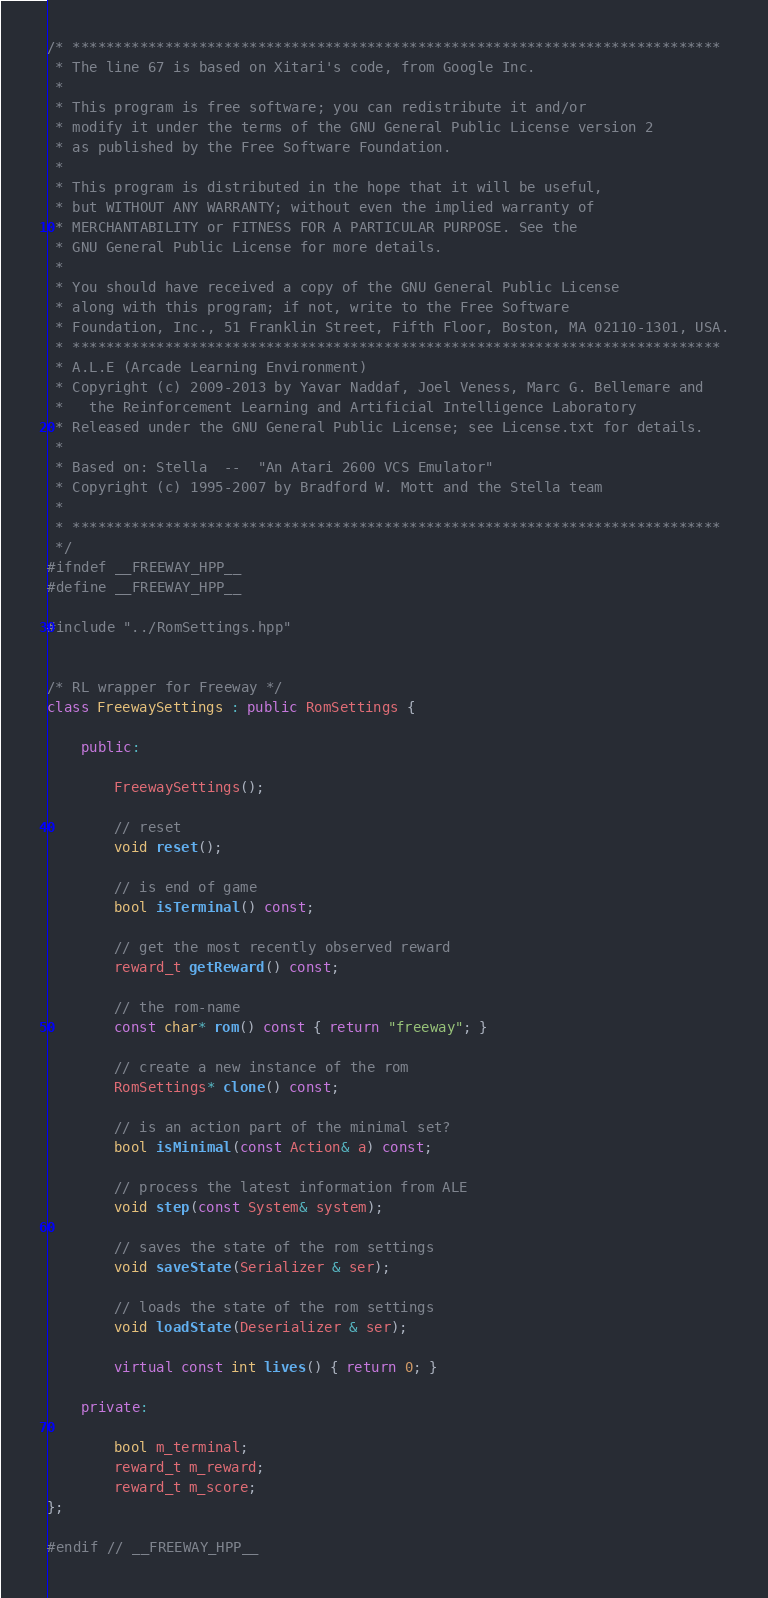<code> <loc_0><loc_0><loc_500><loc_500><_C++_>/* *****************************************************************************
 * The line 67 is based on Xitari's code, from Google Inc.
 *
 * This program is free software; you can redistribute it and/or
 * modify it under the terms of the GNU General Public License version 2
 * as published by the Free Software Foundation.
 *
 * This program is distributed in the hope that it will be useful,
 * but WITHOUT ANY WARRANTY; without even the implied warranty of
 * MERCHANTABILITY or FITNESS FOR A PARTICULAR PURPOSE. See the
 * GNU General Public License for more details.
 *
 * You should have received a copy of the GNU General Public License
 * along with this program; if not, write to the Free Software
 * Foundation, Inc., 51 Franklin Street, Fifth Floor, Boston, MA 02110-1301, USA.
 * *****************************************************************************
 * A.L.E (Arcade Learning Environment)
 * Copyright (c) 2009-2013 by Yavar Naddaf, Joel Veness, Marc G. Bellemare and 
 *   the Reinforcement Learning and Artificial Intelligence Laboratory
 * Released under the GNU General Public License; see License.txt for details. 
 *
 * Based on: Stella  --  "An Atari 2600 VCS Emulator"
 * Copyright (c) 1995-2007 by Bradford W. Mott and the Stella team
 *
 * *****************************************************************************
 */
#ifndef __FREEWAY_HPP__
#define __FREEWAY_HPP__

#include "../RomSettings.hpp"


/* RL wrapper for Freeway */
class FreewaySettings : public RomSettings {

    public:

        FreewaySettings();

        // reset
        void reset();

        // is end of game
        bool isTerminal() const;

        // get the most recently observed reward
        reward_t getReward() const;

        // the rom-name
        const char* rom() const { return "freeway"; }

        // create a new instance of the rom
        RomSettings* clone() const;

        // is an action part of the minimal set?
        bool isMinimal(const Action& a) const;

        // process the latest information from ALE
        void step(const System& system);

        // saves the state of the rom settings
        void saveState(Serializer & ser);
    
        // loads the state of the rom settings
        void loadState(Deserializer & ser);

        virtual const int lives() { return 0; }

    private:

        bool m_terminal;
        reward_t m_reward;
        reward_t m_score;
};

#endif // __FREEWAY_HPP__

</code> 